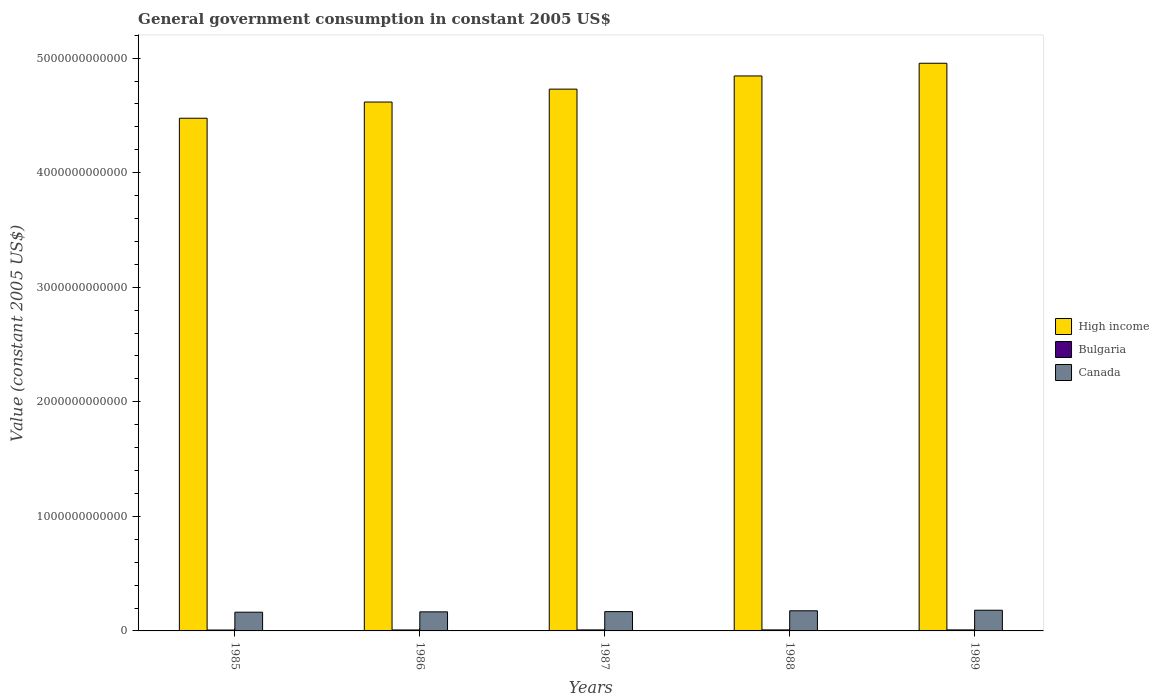How many different coloured bars are there?
Keep it short and to the point. 3. How many groups of bars are there?
Offer a terse response. 5. How many bars are there on the 1st tick from the left?
Make the answer very short. 3. How many bars are there on the 3rd tick from the right?
Your answer should be very brief. 3. What is the label of the 2nd group of bars from the left?
Provide a short and direct response. 1986. What is the government conusmption in Canada in 1986?
Offer a terse response. 1.66e+11. Across all years, what is the maximum government conusmption in High income?
Offer a very short reply. 4.96e+12. Across all years, what is the minimum government conusmption in Bulgaria?
Your answer should be compact. 7.86e+09. In which year was the government conusmption in Canada minimum?
Offer a terse response. 1985. What is the total government conusmption in High income in the graph?
Ensure brevity in your answer.  2.36e+13. What is the difference between the government conusmption in Bulgaria in 1985 and that in 1989?
Your answer should be compact. -9.25e+08. What is the difference between the government conusmption in High income in 1989 and the government conusmption in Canada in 1985?
Keep it short and to the point. 4.79e+12. What is the average government conusmption in Bulgaria per year?
Give a very brief answer. 8.53e+09. In the year 1985, what is the difference between the government conusmption in Canada and government conusmption in High income?
Your answer should be very brief. -4.31e+12. What is the ratio of the government conusmption in High income in 1987 to that in 1988?
Offer a terse response. 0.98. What is the difference between the highest and the second highest government conusmption in Canada?
Your answer should be compact. 4.80e+09. What is the difference between the highest and the lowest government conusmption in Bulgaria?
Your answer should be compact. 9.82e+08. What does the 3rd bar from the right in 1989 represents?
Keep it short and to the point. High income. Is it the case that in every year, the sum of the government conusmption in High income and government conusmption in Canada is greater than the government conusmption in Bulgaria?
Provide a short and direct response. Yes. What is the difference between two consecutive major ticks on the Y-axis?
Offer a terse response. 1.00e+12. Are the values on the major ticks of Y-axis written in scientific E-notation?
Offer a very short reply. No. Does the graph contain any zero values?
Provide a short and direct response. No. How are the legend labels stacked?
Provide a short and direct response. Vertical. What is the title of the graph?
Your response must be concise. General government consumption in constant 2005 US$. What is the label or title of the Y-axis?
Your response must be concise. Value (constant 2005 US$). What is the Value (constant 2005 US$) of High income in 1985?
Keep it short and to the point. 4.48e+12. What is the Value (constant 2005 US$) in Bulgaria in 1985?
Provide a succinct answer. 7.86e+09. What is the Value (constant 2005 US$) in Canada in 1985?
Your answer should be compact. 1.63e+11. What is the Value (constant 2005 US$) of High income in 1986?
Provide a short and direct response. 4.62e+12. What is the Value (constant 2005 US$) in Bulgaria in 1986?
Provide a succinct answer. 8.37e+09. What is the Value (constant 2005 US$) in Canada in 1986?
Your response must be concise. 1.66e+11. What is the Value (constant 2005 US$) in High income in 1987?
Provide a succinct answer. 4.73e+12. What is the Value (constant 2005 US$) of Bulgaria in 1987?
Keep it short and to the point. 8.84e+09. What is the Value (constant 2005 US$) in Canada in 1987?
Ensure brevity in your answer.  1.69e+11. What is the Value (constant 2005 US$) in High income in 1988?
Offer a terse response. 4.84e+12. What is the Value (constant 2005 US$) in Bulgaria in 1988?
Give a very brief answer. 8.78e+09. What is the Value (constant 2005 US$) of Canada in 1988?
Give a very brief answer. 1.76e+11. What is the Value (constant 2005 US$) in High income in 1989?
Your response must be concise. 4.96e+12. What is the Value (constant 2005 US$) of Bulgaria in 1989?
Your response must be concise. 8.78e+09. What is the Value (constant 2005 US$) of Canada in 1989?
Provide a succinct answer. 1.81e+11. Across all years, what is the maximum Value (constant 2005 US$) in High income?
Keep it short and to the point. 4.96e+12. Across all years, what is the maximum Value (constant 2005 US$) in Bulgaria?
Offer a terse response. 8.84e+09. Across all years, what is the maximum Value (constant 2005 US$) in Canada?
Keep it short and to the point. 1.81e+11. Across all years, what is the minimum Value (constant 2005 US$) in High income?
Your response must be concise. 4.48e+12. Across all years, what is the minimum Value (constant 2005 US$) of Bulgaria?
Ensure brevity in your answer.  7.86e+09. Across all years, what is the minimum Value (constant 2005 US$) of Canada?
Your response must be concise. 1.63e+11. What is the total Value (constant 2005 US$) in High income in the graph?
Provide a short and direct response. 2.36e+13. What is the total Value (constant 2005 US$) of Bulgaria in the graph?
Your response must be concise. 4.26e+1. What is the total Value (constant 2005 US$) of Canada in the graph?
Offer a terse response. 8.55e+11. What is the difference between the Value (constant 2005 US$) of High income in 1985 and that in 1986?
Keep it short and to the point. -1.42e+11. What is the difference between the Value (constant 2005 US$) in Bulgaria in 1985 and that in 1986?
Offer a terse response. -5.15e+08. What is the difference between the Value (constant 2005 US$) of Canada in 1985 and that in 1986?
Offer a terse response. -3.05e+09. What is the difference between the Value (constant 2005 US$) of High income in 1985 and that in 1987?
Keep it short and to the point. -2.54e+11. What is the difference between the Value (constant 2005 US$) in Bulgaria in 1985 and that in 1987?
Keep it short and to the point. -9.82e+08. What is the difference between the Value (constant 2005 US$) of Canada in 1985 and that in 1987?
Your answer should be very brief. -5.07e+09. What is the difference between the Value (constant 2005 US$) in High income in 1985 and that in 1988?
Offer a very short reply. -3.69e+11. What is the difference between the Value (constant 2005 US$) in Bulgaria in 1985 and that in 1988?
Your answer should be very brief. -9.18e+08. What is the difference between the Value (constant 2005 US$) in Canada in 1985 and that in 1988?
Give a very brief answer. -1.23e+1. What is the difference between the Value (constant 2005 US$) of High income in 1985 and that in 1989?
Offer a very short reply. -4.80e+11. What is the difference between the Value (constant 2005 US$) in Bulgaria in 1985 and that in 1989?
Offer a terse response. -9.25e+08. What is the difference between the Value (constant 2005 US$) of Canada in 1985 and that in 1989?
Give a very brief answer. -1.71e+1. What is the difference between the Value (constant 2005 US$) of High income in 1986 and that in 1987?
Your answer should be compact. -1.13e+11. What is the difference between the Value (constant 2005 US$) of Bulgaria in 1986 and that in 1987?
Your response must be concise. -4.68e+08. What is the difference between the Value (constant 2005 US$) in Canada in 1986 and that in 1987?
Offer a terse response. -2.02e+09. What is the difference between the Value (constant 2005 US$) in High income in 1986 and that in 1988?
Offer a terse response. -2.28e+11. What is the difference between the Value (constant 2005 US$) in Bulgaria in 1986 and that in 1988?
Your response must be concise. -4.03e+08. What is the difference between the Value (constant 2005 US$) of Canada in 1986 and that in 1988?
Provide a short and direct response. -9.29e+09. What is the difference between the Value (constant 2005 US$) of High income in 1986 and that in 1989?
Your answer should be compact. -3.39e+11. What is the difference between the Value (constant 2005 US$) in Bulgaria in 1986 and that in 1989?
Provide a succinct answer. -4.10e+08. What is the difference between the Value (constant 2005 US$) in Canada in 1986 and that in 1989?
Offer a terse response. -1.41e+1. What is the difference between the Value (constant 2005 US$) in High income in 1987 and that in 1988?
Offer a very short reply. -1.15e+11. What is the difference between the Value (constant 2005 US$) in Bulgaria in 1987 and that in 1988?
Make the answer very short. 6.43e+07. What is the difference between the Value (constant 2005 US$) in Canada in 1987 and that in 1988?
Provide a succinct answer. -7.27e+09. What is the difference between the Value (constant 2005 US$) of High income in 1987 and that in 1989?
Your response must be concise. -2.26e+11. What is the difference between the Value (constant 2005 US$) in Bulgaria in 1987 and that in 1989?
Offer a very short reply. 5.76e+07. What is the difference between the Value (constant 2005 US$) in Canada in 1987 and that in 1989?
Your answer should be compact. -1.21e+1. What is the difference between the Value (constant 2005 US$) of High income in 1988 and that in 1989?
Give a very brief answer. -1.11e+11. What is the difference between the Value (constant 2005 US$) of Bulgaria in 1988 and that in 1989?
Offer a terse response. -6.71e+06. What is the difference between the Value (constant 2005 US$) of Canada in 1988 and that in 1989?
Your answer should be very brief. -4.80e+09. What is the difference between the Value (constant 2005 US$) of High income in 1985 and the Value (constant 2005 US$) of Bulgaria in 1986?
Offer a very short reply. 4.47e+12. What is the difference between the Value (constant 2005 US$) in High income in 1985 and the Value (constant 2005 US$) in Canada in 1986?
Keep it short and to the point. 4.31e+12. What is the difference between the Value (constant 2005 US$) of Bulgaria in 1985 and the Value (constant 2005 US$) of Canada in 1986?
Make the answer very short. -1.59e+11. What is the difference between the Value (constant 2005 US$) in High income in 1985 and the Value (constant 2005 US$) in Bulgaria in 1987?
Provide a short and direct response. 4.47e+12. What is the difference between the Value (constant 2005 US$) of High income in 1985 and the Value (constant 2005 US$) of Canada in 1987?
Keep it short and to the point. 4.31e+12. What is the difference between the Value (constant 2005 US$) of Bulgaria in 1985 and the Value (constant 2005 US$) of Canada in 1987?
Your answer should be compact. -1.61e+11. What is the difference between the Value (constant 2005 US$) in High income in 1985 and the Value (constant 2005 US$) in Bulgaria in 1988?
Provide a short and direct response. 4.47e+12. What is the difference between the Value (constant 2005 US$) of High income in 1985 and the Value (constant 2005 US$) of Canada in 1988?
Your answer should be compact. 4.30e+12. What is the difference between the Value (constant 2005 US$) of Bulgaria in 1985 and the Value (constant 2005 US$) of Canada in 1988?
Ensure brevity in your answer.  -1.68e+11. What is the difference between the Value (constant 2005 US$) in High income in 1985 and the Value (constant 2005 US$) in Bulgaria in 1989?
Provide a short and direct response. 4.47e+12. What is the difference between the Value (constant 2005 US$) of High income in 1985 and the Value (constant 2005 US$) of Canada in 1989?
Your answer should be very brief. 4.29e+12. What is the difference between the Value (constant 2005 US$) in Bulgaria in 1985 and the Value (constant 2005 US$) in Canada in 1989?
Make the answer very short. -1.73e+11. What is the difference between the Value (constant 2005 US$) in High income in 1986 and the Value (constant 2005 US$) in Bulgaria in 1987?
Ensure brevity in your answer.  4.61e+12. What is the difference between the Value (constant 2005 US$) in High income in 1986 and the Value (constant 2005 US$) in Canada in 1987?
Offer a terse response. 4.45e+12. What is the difference between the Value (constant 2005 US$) of Bulgaria in 1986 and the Value (constant 2005 US$) of Canada in 1987?
Your answer should be very brief. -1.60e+11. What is the difference between the Value (constant 2005 US$) in High income in 1986 and the Value (constant 2005 US$) in Bulgaria in 1988?
Keep it short and to the point. 4.61e+12. What is the difference between the Value (constant 2005 US$) of High income in 1986 and the Value (constant 2005 US$) of Canada in 1988?
Your answer should be compact. 4.44e+12. What is the difference between the Value (constant 2005 US$) in Bulgaria in 1986 and the Value (constant 2005 US$) in Canada in 1988?
Make the answer very short. -1.67e+11. What is the difference between the Value (constant 2005 US$) in High income in 1986 and the Value (constant 2005 US$) in Bulgaria in 1989?
Provide a succinct answer. 4.61e+12. What is the difference between the Value (constant 2005 US$) in High income in 1986 and the Value (constant 2005 US$) in Canada in 1989?
Your answer should be very brief. 4.44e+12. What is the difference between the Value (constant 2005 US$) of Bulgaria in 1986 and the Value (constant 2005 US$) of Canada in 1989?
Give a very brief answer. -1.72e+11. What is the difference between the Value (constant 2005 US$) in High income in 1987 and the Value (constant 2005 US$) in Bulgaria in 1988?
Your response must be concise. 4.72e+12. What is the difference between the Value (constant 2005 US$) of High income in 1987 and the Value (constant 2005 US$) of Canada in 1988?
Offer a very short reply. 4.55e+12. What is the difference between the Value (constant 2005 US$) of Bulgaria in 1987 and the Value (constant 2005 US$) of Canada in 1988?
Offer a terse response. -1.67e+11. What is the difference between the Value (constant 2005 US$) in High income in 1987 and the Value (constant 2005 US$) in Bulgaria in 1989?
Provide a short and direct response. 4.72e+12. What is the difference between the Value (constant 2005 US$) in High income in 1987 and the Value (constant 2005 US$) in Canada in 1989?
Provide a succinct answer. 4.55e+12. What is the difference between the Value (constant 2005 US$) of Bulgaria in 1987 and the Value (constant 2005 US$) of Canada in 1989?
Provide a succinct answer. -1.72e+11. What is the difference between the Value (constant 2005 US$) of High income in 1988 and the Value (constant 2005 US$) of Bulgaria in 1989?
Offer a terse response. 4.84e+12. What is the difference between the Value (constant 2005 US$) in High income in 1988 and the Value (constant 2005 US$) in Canada in 1989?
Make the answer very short. 4.66e+12. What is the difference between the Value (constant 2005 US$) in Bulgaria in 1988 and the Value (constant 2005 US$) in Canada in 1989?
Your answer should be very brief. -1.72e+11. What is the average Value (constant 2005 US$) of High income per year?
Your response must be concise. 4.72e+12. What is the average Value (constant 2005 US$) of Bulgaria per year?
Provide a short and direct response. 8.53e+09. What is the average Value (constant 2005 US$) of Canada per year?
Your answer should be very brief. 1.71e+11. In the year 1985, what is the difference between the Value (constant 2005 US$) in High income and Value (constant 2005 US$) in Bulgaria?
Make the answer very short. 4.47e+12. In the year 1985, what is the difference between the Value (constant 2005 US$) of High income and Value (constant 2005 US$) of Canada?
Provide a short and direct response. 4.31e+12. In the year 1985, what is the difference between the Value (constant 2005 US$) of Bulgaria and Value (constant 2005 US$) of Canada?
Your answer should be compact. -1.56e+11. In the year 1986, what is the difference between the Value (constant 2005 US$) of High income and Value (constant 2005 US$) of Bulgaria?
Ensure brevity in your answer.  4.61e+12. In the year 1986, what is the difference between the Value (constant 2005 US$) in High income and Value (constant 2005 US$) in Canada?
Your answer should be compact. 4.45e+12. In the year 1986, what is the difference between the Value (constant 2005 US$) in Bulgaria and Value (constant 2005 US$) in Canada?
Offer a terse response. -1.58e+11. In the year 1987, what is the difference between the Value (constant 2005 US$) of High income and Value (constant 2005 US$) of Bulgaria?
Make the answer very short. 4.72e+12. In the year 1987, what is the difference between the Value (constant 2005 US$) of High income and Value (constant 2005 US$) of Canada?
Provide a succinct answer. 4.56e+12. In the year 1987, what is the difference between the Value (constant 2005 US$) in Bulgaria and Value (constant 2005 US$) in Canada?
Your answer should be compact. -1.60e+11. In the year 1988, what is the difference between the Value (constant 2005 US$) in High income and Value (constant 2005 US$) in Bulgaria?
Provide a short and direct response. 4.84e+12. In the year 1988, what is the difference between the Value (constant 2005 US$) of High income and Value (constant 2005 US$) of Canada?
Offer a very short reply. 4.67e+12. In the year 1988, what is the difference between the Value (constant 2005 US$) of Bulgaria and Value (constant 2005 US$) of Canada?
Your answer should be compact. -1.67e+11. In the year 1989, what is the difference between the Value (constant 2005 US$) in High income and Value (constant 2005 US$) in Bulgaria?
Give a very brief answer. 4.95e+12. In the year 1989, what is the difference between the Value (constant 2005 US$) in High income and Value (constant 2005 US$) in Canada?
Make the answer very short. 4.77e+12. In the year 1989, what is the difference between the Value (constant 2005 US$) in Bulgaria and Value (constant 2005 US$) in Canada?
Your response must be concise. -1.72e+11. What is the ratio of the Value (constant 2005 US$) in High income in 1985 to that in 1986?
Give a very brief answer. 0.97. What is the ratio of the Value (constant 2005 US$) in Bulgaria in 1985 to that in 1986?
Offer a terse response. 0.94. What is the ratio of the Value (constant 2005 US$) in Canada in 1985 to that in 1986?
Keep it short and to the point. 0.98. What is the ratio of the Value (constant 2005 US$) of High income in 1985 to that in 1987?
Give a very brief answer. 0.95. What is the ratio of the Value (constant 2005 US$) in Canada in 1985 to that in 1987?
Keep it short and to the point. 0.97. What is the ratio of the Value (constant 2005 US$) in High income in 1985 to that in 1988?
Provide a succinct answer. 0.92. What is the ratio of the Value (constant 2005 US$) of Bulgaria in 1985 to that in 1988?
Provide a succinct answer. 0.9. What is the ratio of the Value (constant 2005 US$) of Canada in 1985 to that in 1988?
Your answer should be compact. 0.93. What is the ratio of the Value (constant 2005 US$) in High income in 1985 to that in 1989?
Keep it short and to the point. 0.9. What is the ratio of the Value (constant 2005 US$) of Bulgaria in 1985 to that in 1989?
Offer a terse response. 0.89. What is the ratio of the Value (constant 2005 US$) in Canada in 1985 to that in 1989?
Make the answer very short. 0.91. What is the ratio of the Value (constant 2005 US$) of High income in 1986 to that in 1987?
Your answer should be compact. 0.98. What is the ratio of the Value (constant 2005 US$) of Bulgaria in 1986 to that in 1987?
Your response must be concise. 0.95. What is the ratio of the Value (constant 2005 US$) in High income in 1986 to that in 1988?
Your answer should be very brief. 0.95. What is the ratio of the Value (constant 2005 US$) of Bulgaria in 1986 to that in 1988?
Your answer should be very brief. 0.95. What is the ratio of the Value (constant 2005 US$) of Canada in 1986 to that in 1988?
Make the answer very short. 0.95. What is the ratio of the Value (constant 2005 US$) of High income in 1986 to that in 1989?
Your answer should be very brief. 0.93. What is the ratio of the Value (constant 2005 US$) of Bulgaria in 1986 to that in 1989?
Offer a terse response. 0.95. What is the ratio of the Value (constant 2005 US$) in Canada in 1986 to that in 1989?
Your response must be concise. 0.92. What is the ratio of the Value (constant 2005 US$) of High income in 1987 to that in 1988?
Your answer should be compact. 0.98. What is the ratio of the Value (constant 2005 US$) of Bulgaria in 1987 to that in 1988?
Provide a succinct answer. 1.01. What is the ratio of the Value (constant 2005 US$) of Canada in 1987 to that in 1988?
Offer a terse response. 0.96. What is the ratio of the Value (constant 2005 US$) in High income in 1987 to that in 1989?
Offer a terse response. 0.95. What is the ratio of the Value (constant 2005 US$) of Bulgaria in 1987 to that in 1989?
Your answer should be very brief. 1.01. What is the ratio of the Value (constant 2005 US$) in Canada in 1987 to that in 1989?
Your answer should be very brief. 0.93. What is the ratio of the Value (constant 2005 US$) in High income in 1988 to that in 1989?
Offer a very short reply. 0.98. What is the ratio of the Value (constant 2005 US$) of Bulgaria in 1988 to that in 1989?
Offer a very short reply. 1. What is the ratio of the Value (constant 2005 US$) in Canada in 1988 to that in 1989?
Keep it short and to the point. 0.97. What is the difference between the highest and the second highest Value (constant 2005 US$) of High income?
Keep it short and to the point. 1.11e+11. What is the difference between the highest and the second highest Value (constant 2005 US$) of Bulgaria?
Keep it short and to the point. 5.76e+07. What is the difference between the highest and the second highest Value (constant 2005 US$) in Canada?
Offer a terse response. 4.80e+09. What is the difference between the highest and the lowest Value (constant 2005 US$) of High income?
Provide a short and direct response. 4.80e+11. What is the difference between the highest and the lowest Value (constant 2005 US$) in Bulgaria?
Make the answer very short. 9.82e+08. What is the difference between the highest and the lowest Value (constant 2005 US$) of Canada?
Your answer should be compact. 1.71e+1. 